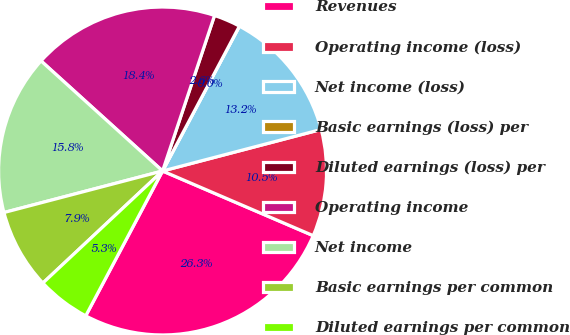Convert chart to OTSL. <chart><loc_0><loc_0><loc_500><loc_500><pie_chart><fcel>Revenues<fcel>Operating income (loss)<fcel>Net income (loss)<fcel>Basic earnings (loss) per<fcel>Diluted earnings (loss) per<fcel>Operating income<fcel>Net income<fcel>Basic earnings per common<fcel>Diluted earnings per common<nl><fcel>26.31%<fcel>10.53%<fcel>13.16%<fcel>0.0%<fcel>2.63%<fcel>18.42%<fcel>15.79%<fcel>7.9%<fcel>5.26%<nl></chart> 